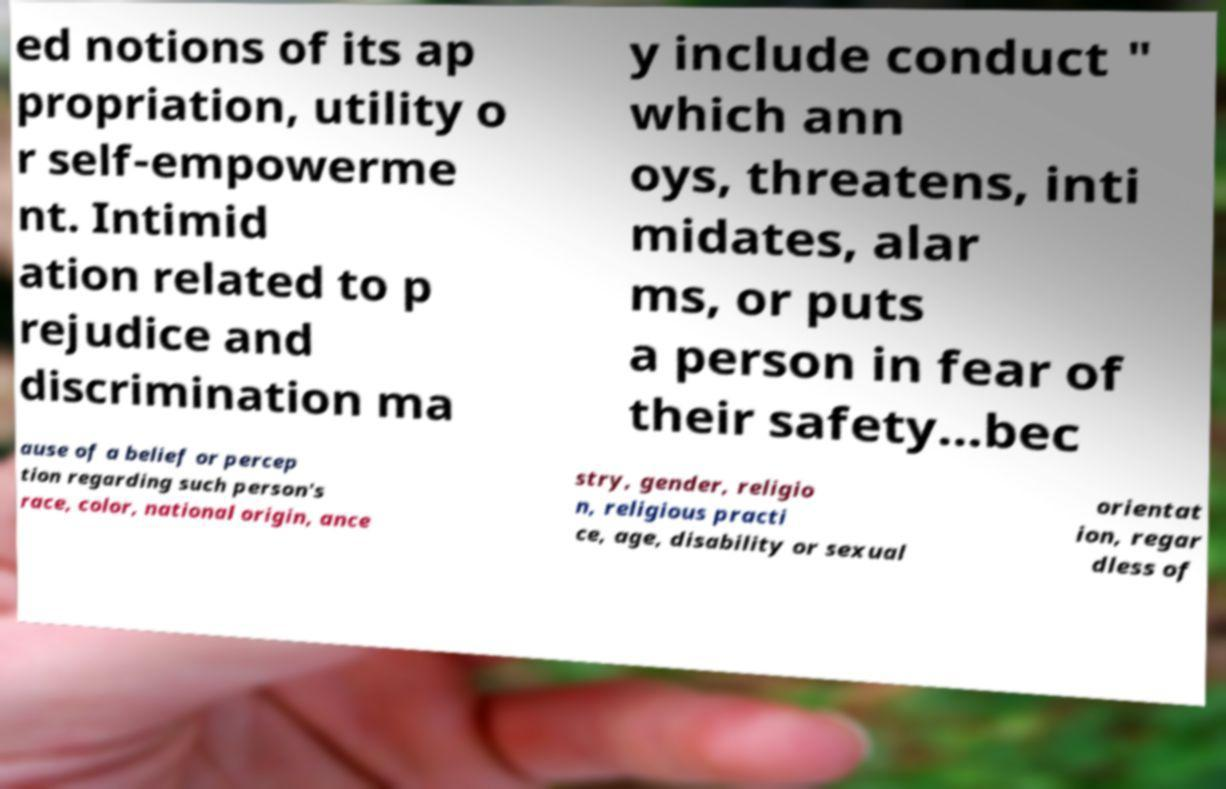Can you read and provide the text displayed in the image?This photo seems to have some interesting text. Can you extract and type it out for me? ed notions of its ap propriation, utility o r self-empowerme nt. Intimid ation related to p rejudice and discrimination ma y include conduct " which ann oys, threatens, inti midates, alar ms, or puts a person in fear of their safety...bec ause of a belief or percep tion regarding such person's race, color, national origin, ance stry, gender, religio n, religious practi ce, age, disability or sexual orientat ion, regar dless of 